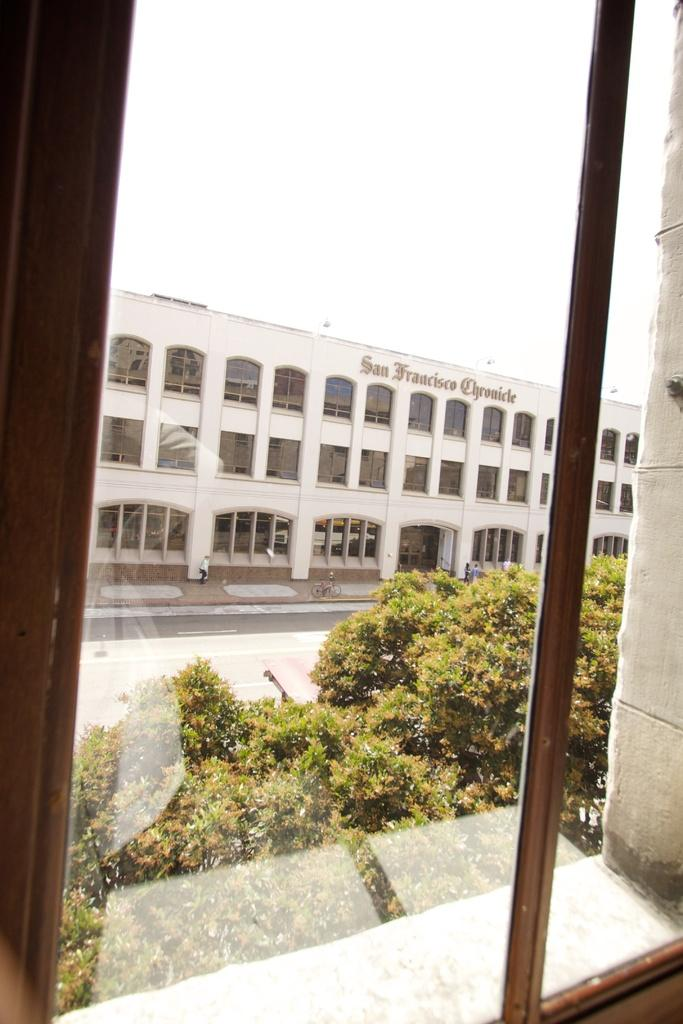What can be seen in the image that provides a view of the outdoors? There is a window in the image that provides a view of the outdoors. What is present in the image that separates the indoor and outdoor spaces? There is a wall in the image that separates the indoor and outdoor spaces. What can be seen in the background of the image? There is a group of trees, a building with windows, people on the ground, and a bicycle parked aside in the background. What is visible in the sky in the background of the image? The sky is visible in the background of the image. What type of knot is being used to secure the yoke in the image? There is no yoke or knot present in the image. What answer is being provided by the person in the image? There are no people providing answers in the image. 